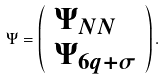<formula> <loc_0><loc_0><loc_500><loc_500>\Psi = \left ( \begin{array} { l } \Psi _ { N N } \\ \Psi _ { 6 q + \sigma } \end{array} \right ) .</formula> 